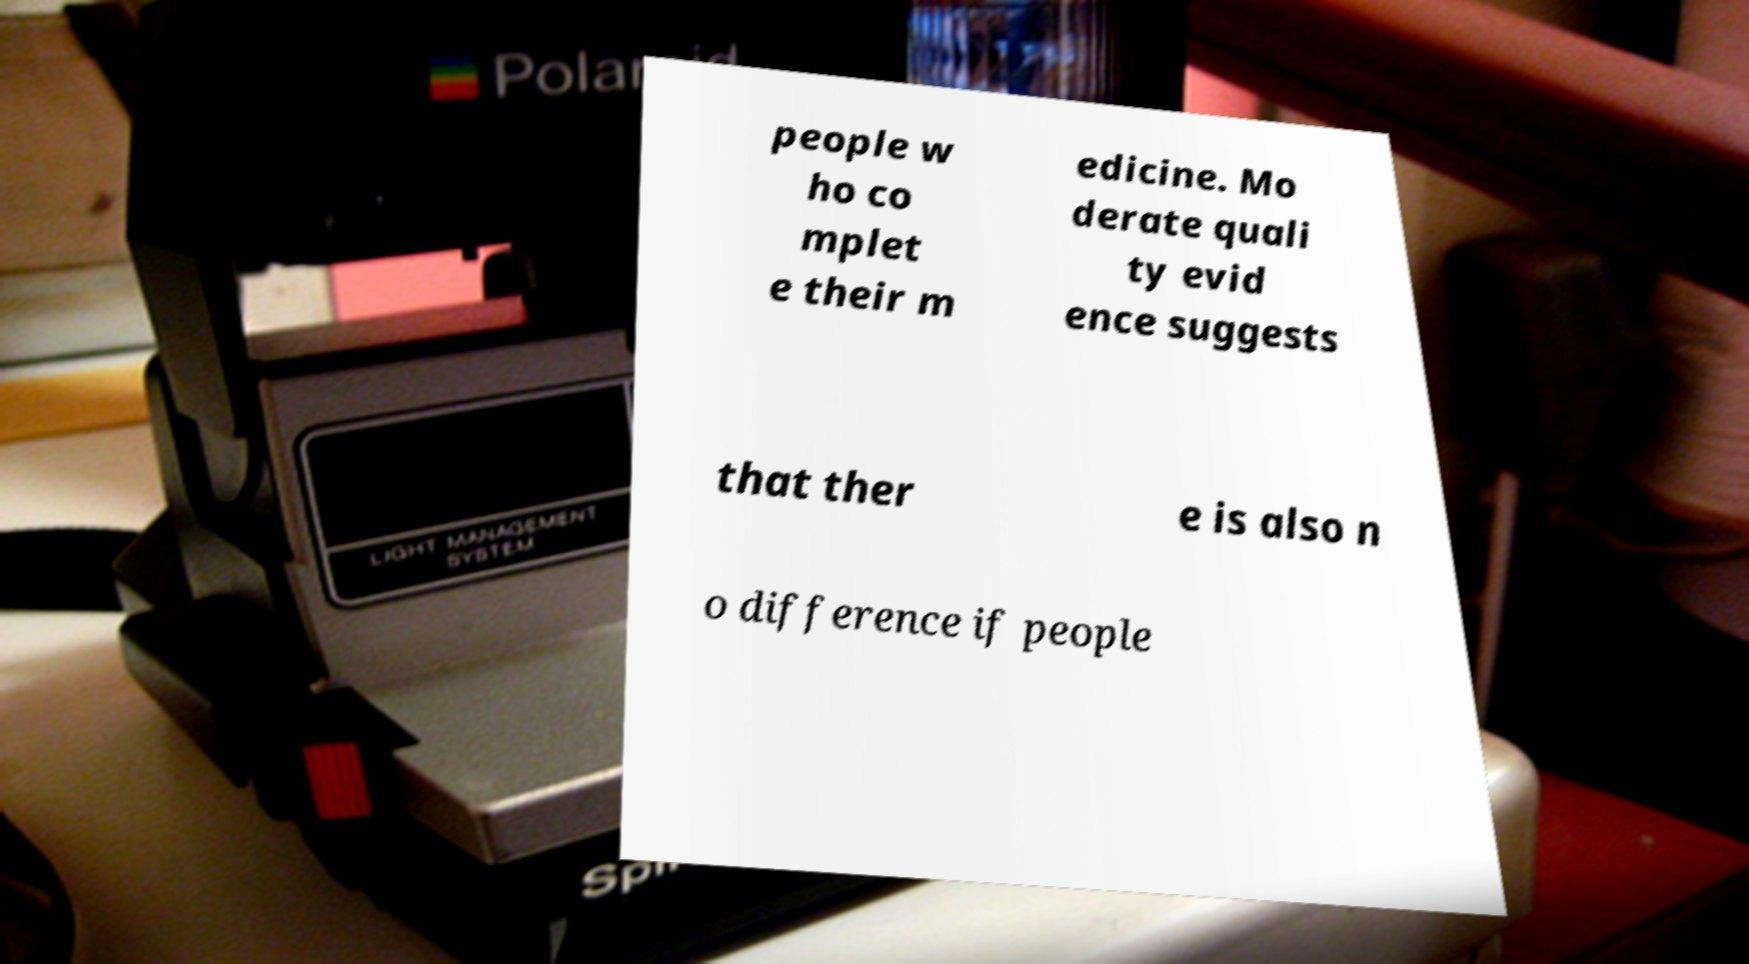Could you extract and type out the text from this image? people w ho co mplet e their m edicine. Mo derate quali ty evid ence suggests that ther e is also n o difference if people 